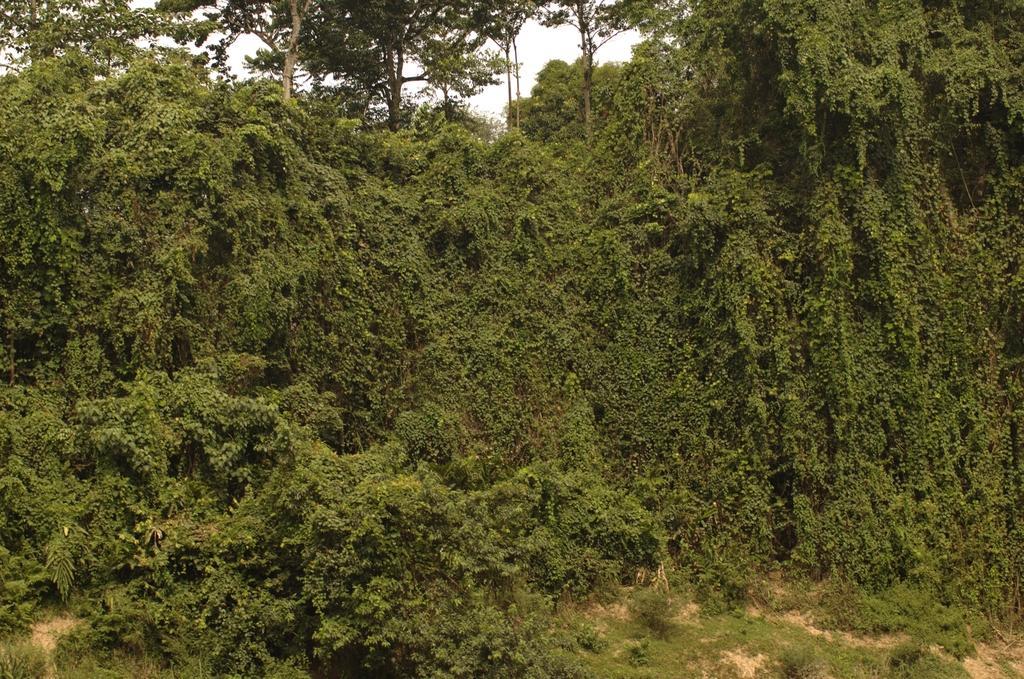Describe this image in one or two sentences. In this image I see number of trees and I see few plants and I see the sky in the background. 